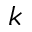Convert formula to latex. <formula><loc_0><loc_0><loc_500><loc_500>k</formula> 